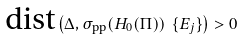<formula> <loc_0><loc_0><loc_500><loc_500>\text {dist} \left ( \Delta , \sigma _ { \text {pp} } ( H _ { 0 } ( \Pi ) ) \ \{ E _ { j } \} \right ) > 0</formula> 